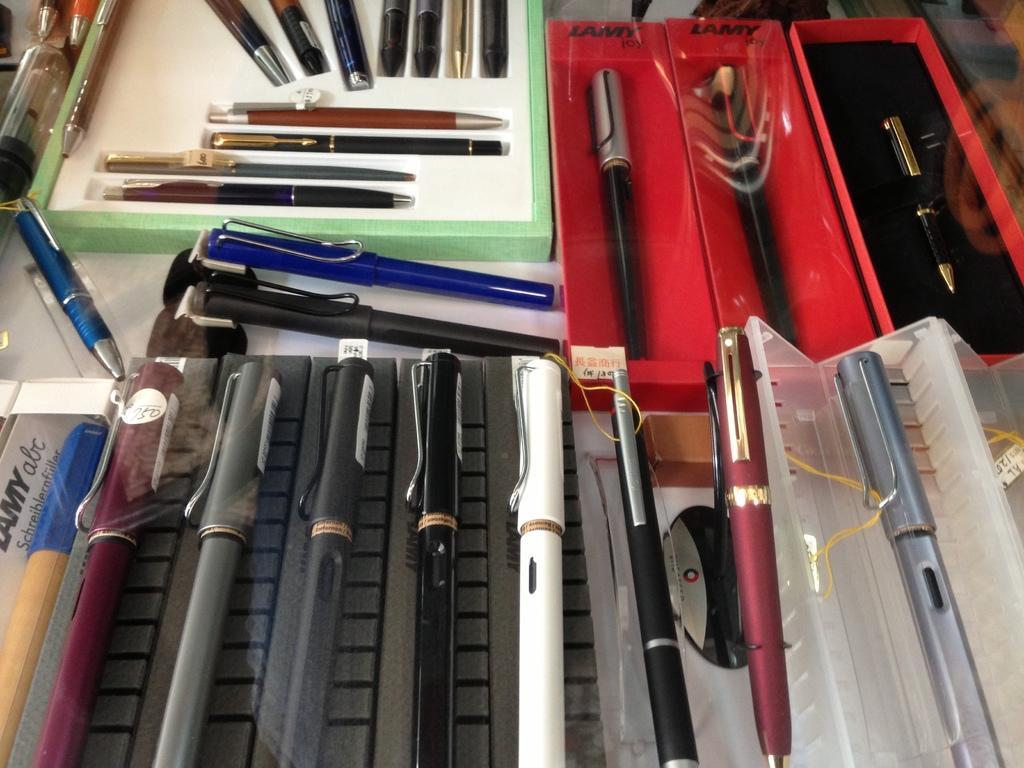Please provide a concise description of this image. In this image I can see few pens in the boxes and the pens are in multi color. 